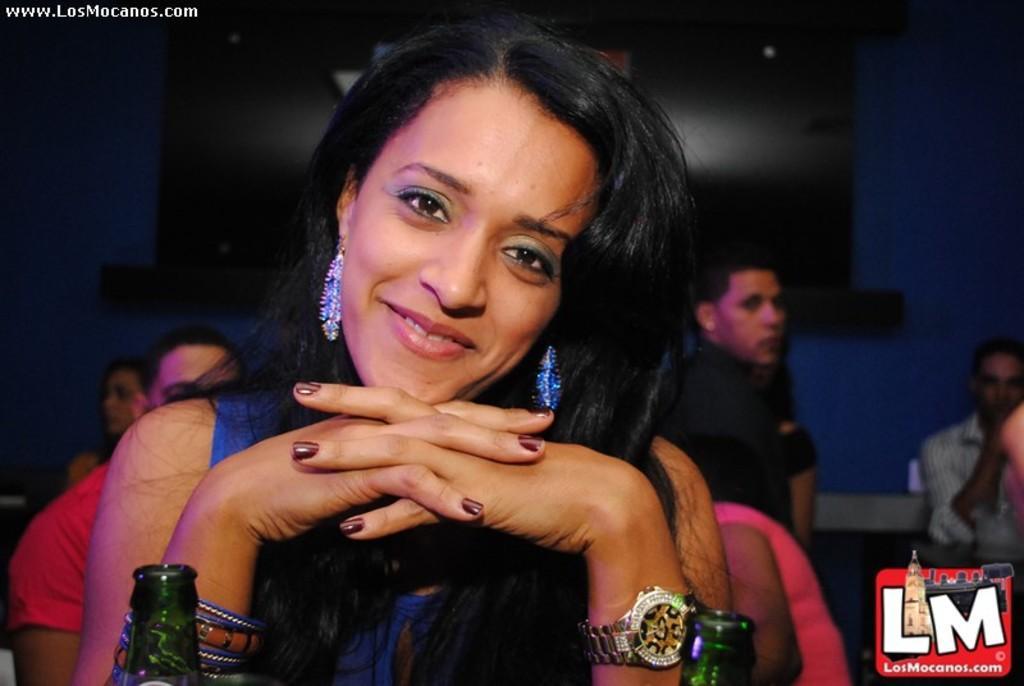Please provide a concise description of this image. There is a woman smiling, in front of her we can see bottles. In the background we can see people, wall and television. In the bottom right side of the image we can see logo. In the top left side of the image we can see text. 